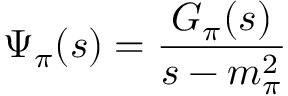<formula> <loc_0><loc_0><loc_500><loc_500>\Psi _ { \pi } ( s ) = \frac { G _ { \pi } ( s ) } { s - m _ { \pi } ^ { 2 } }</formula> 